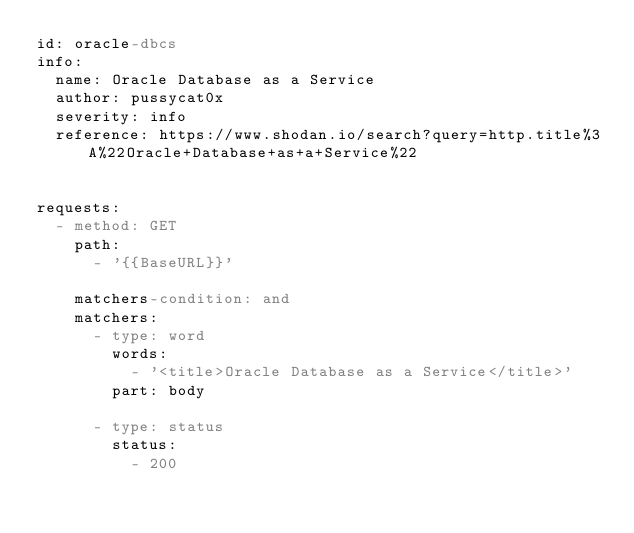Convert code to text. <code><loc_0><loc_0><loc_500><loc_500><_YAML_>id: oracle-dbcs
info:
  name: Oracle Database as a Service
  author: pussycat0x
  severity: info
  reference: https://www.shodan.io/search?query=http.title%3A%22Oracle+Database+as+a+Service%22
 

requests:
  - method: GET
    path:
      - '{{BaseURL}}'

    matchers-condition: and
    matchers:
      - type: word
        words:
          - '<title>Oracle Database as a Service</title>'
        part: body

      - type: status
        status:
          - 200
</code> 